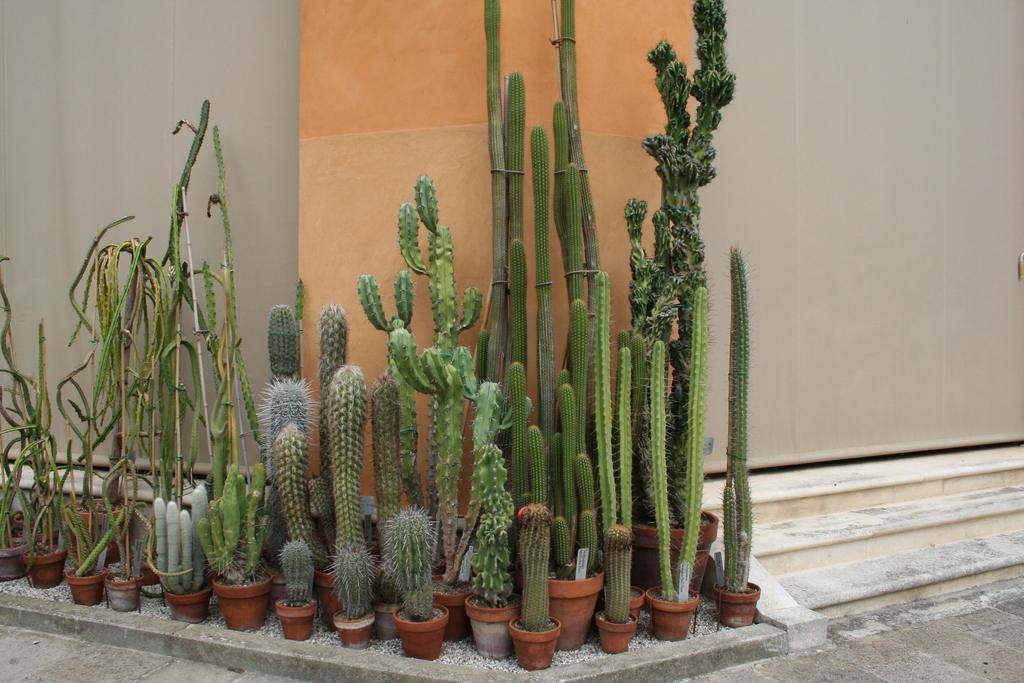Can you describe this image briefly? In this picture we can see some plants in the pot. And this is the wall. 